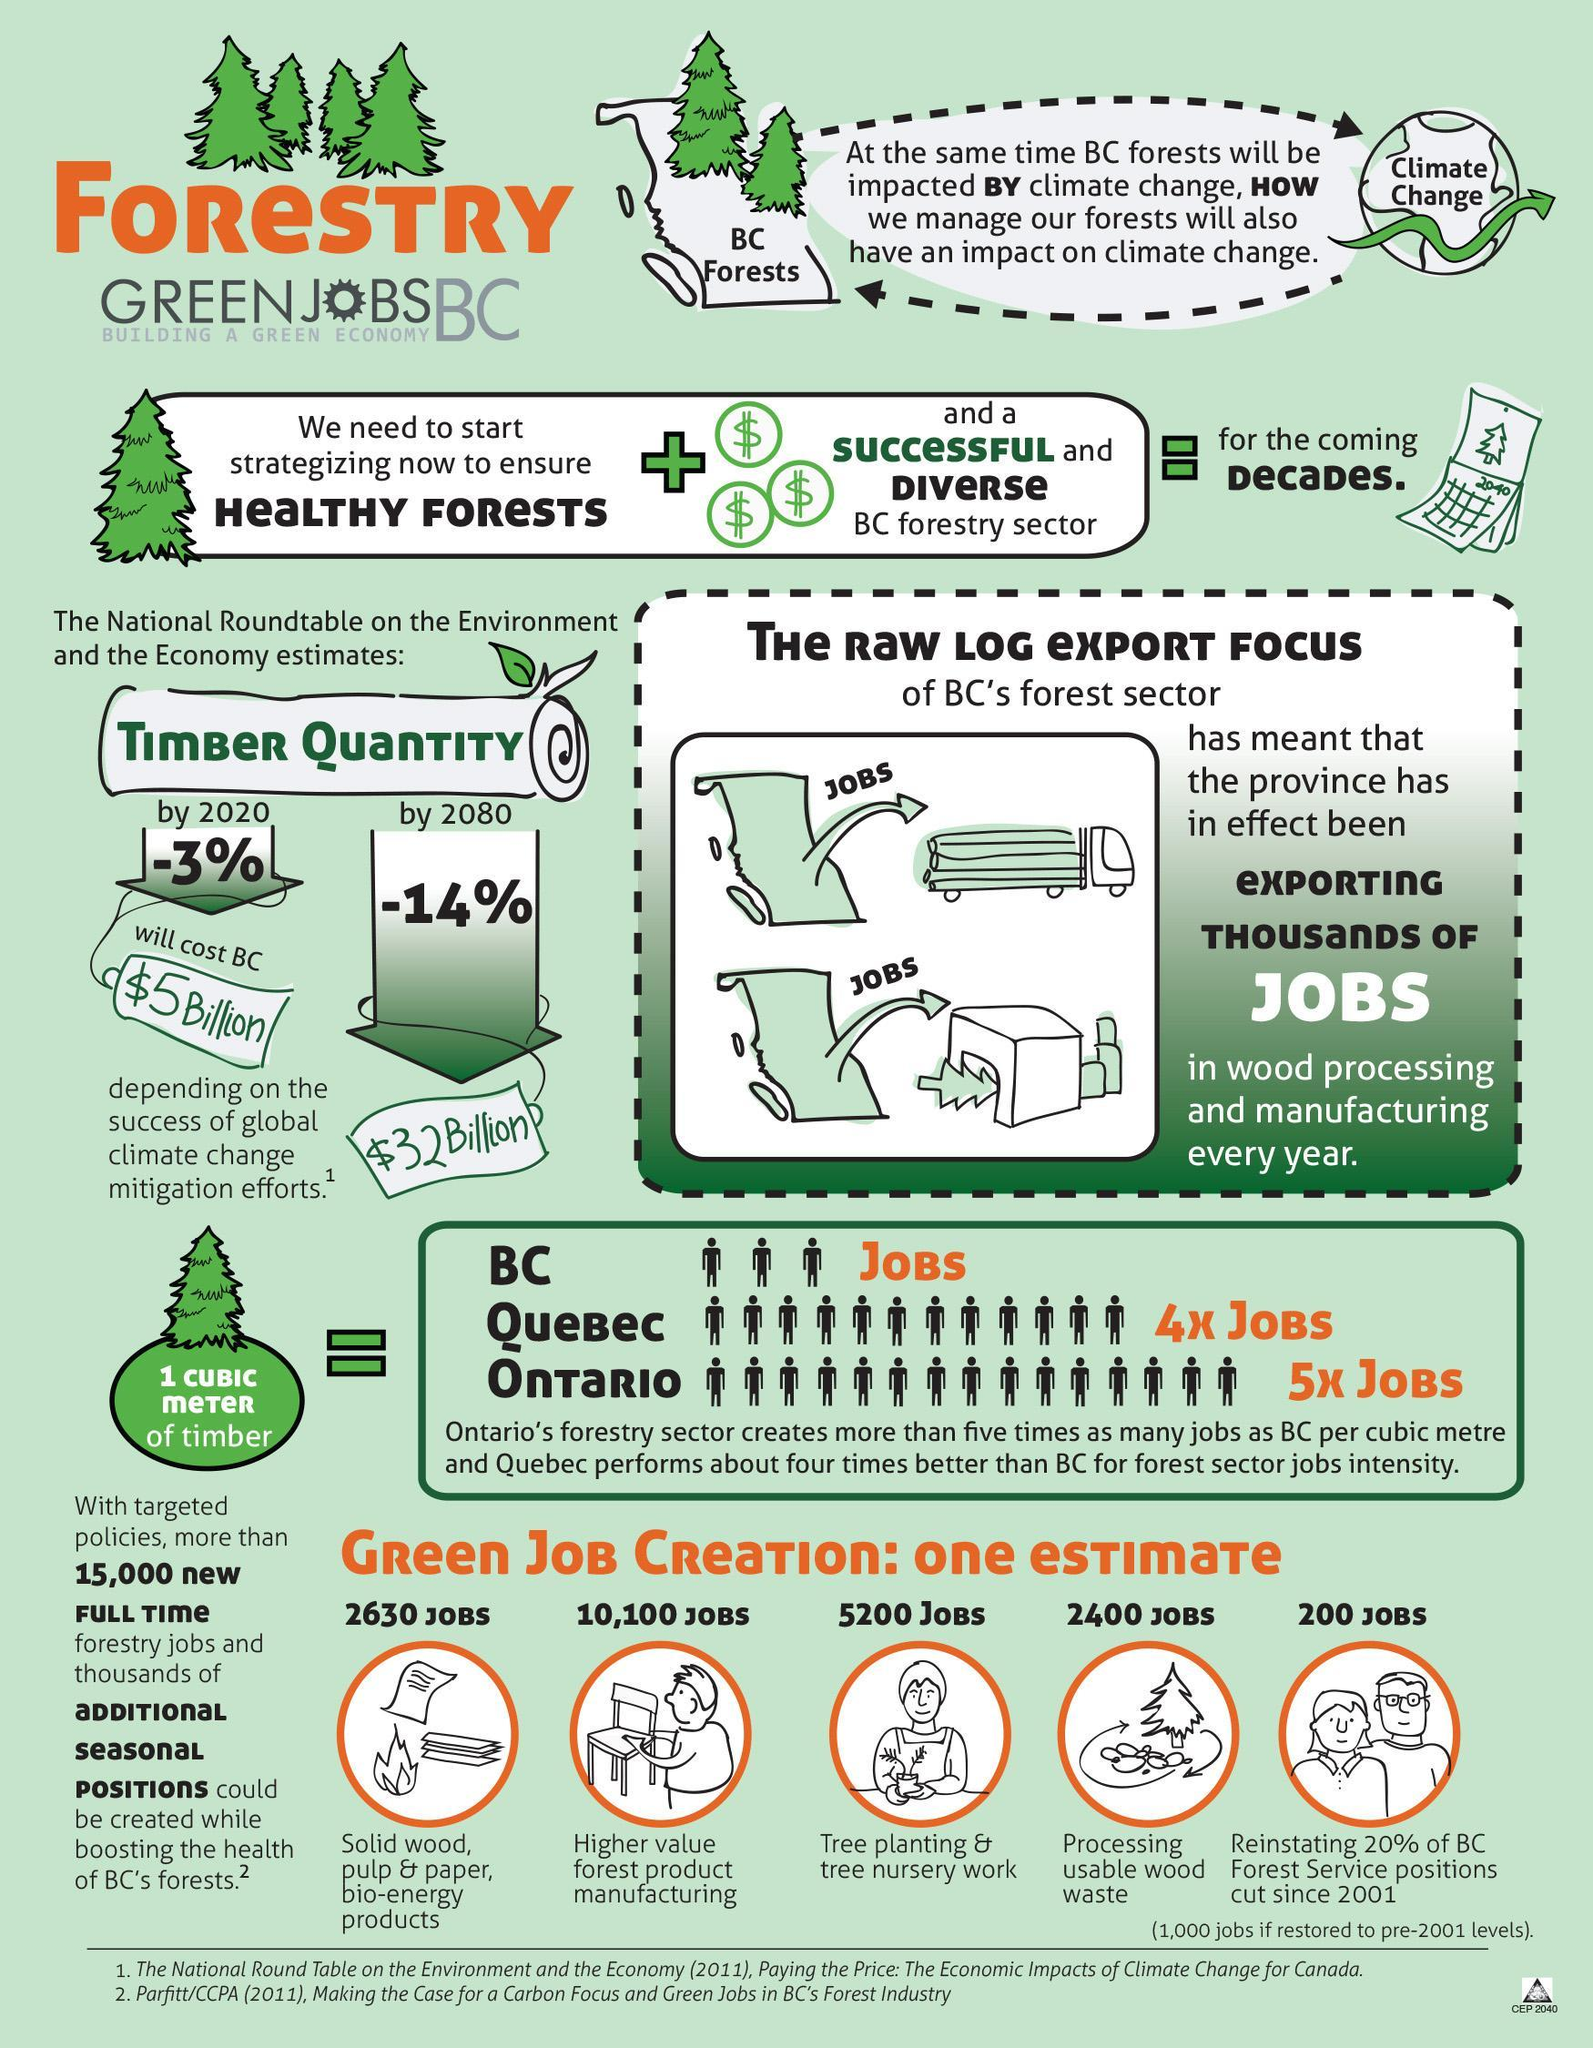How many jobs can be created for planting and nursery work, 2630, 10,100, or 5200 jobs??
Answer the question with a short phrase. 5200 jobs Which sector will have the highest number of green jobs created? Higher value forest product manufacturing 